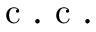Convert formula to latex. <formula><loc_0><loc_0><loc_500><loc_500>c . c .</formula> 